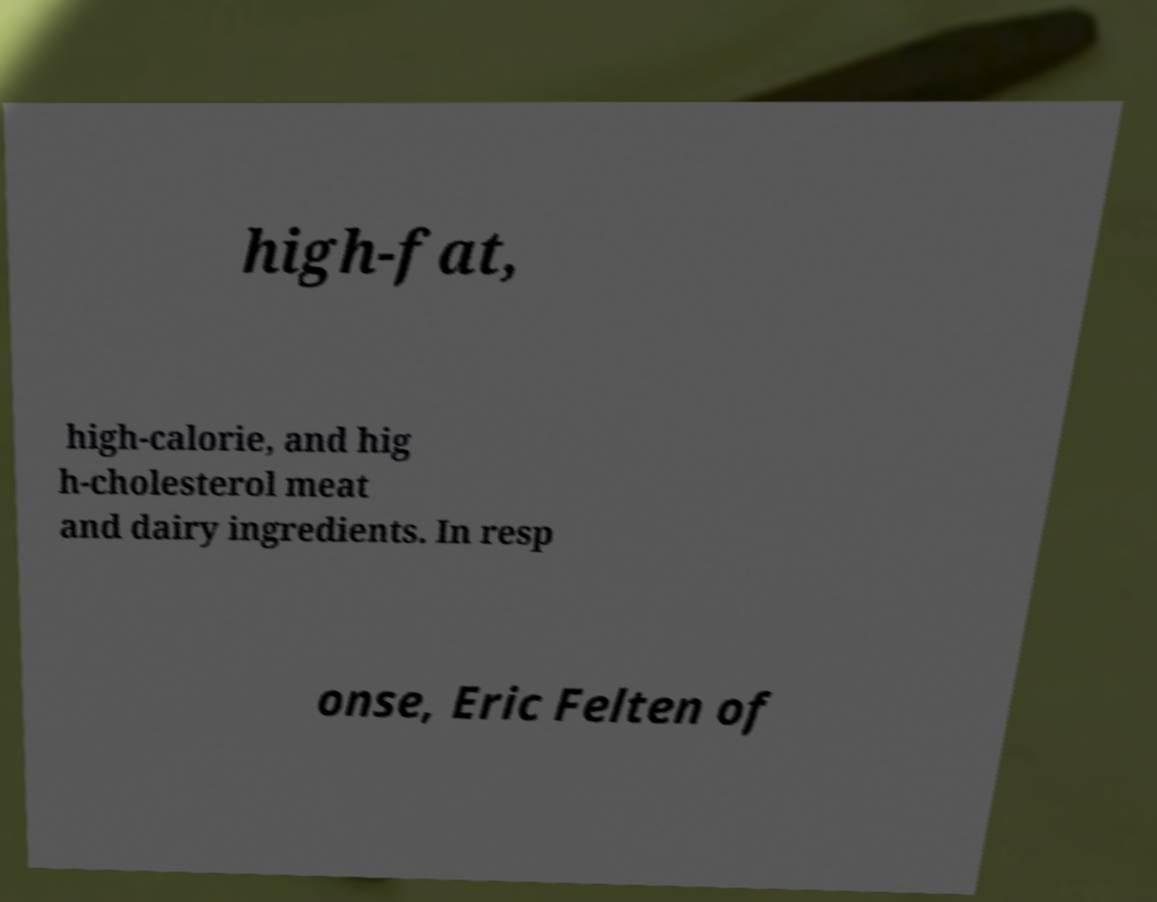Can you accurately transcribe the text from the provided image for me? high-fat, high-calorie, and hig h-cholesterol meat and dairy ingredients. In resp onse, Eric Felten of 